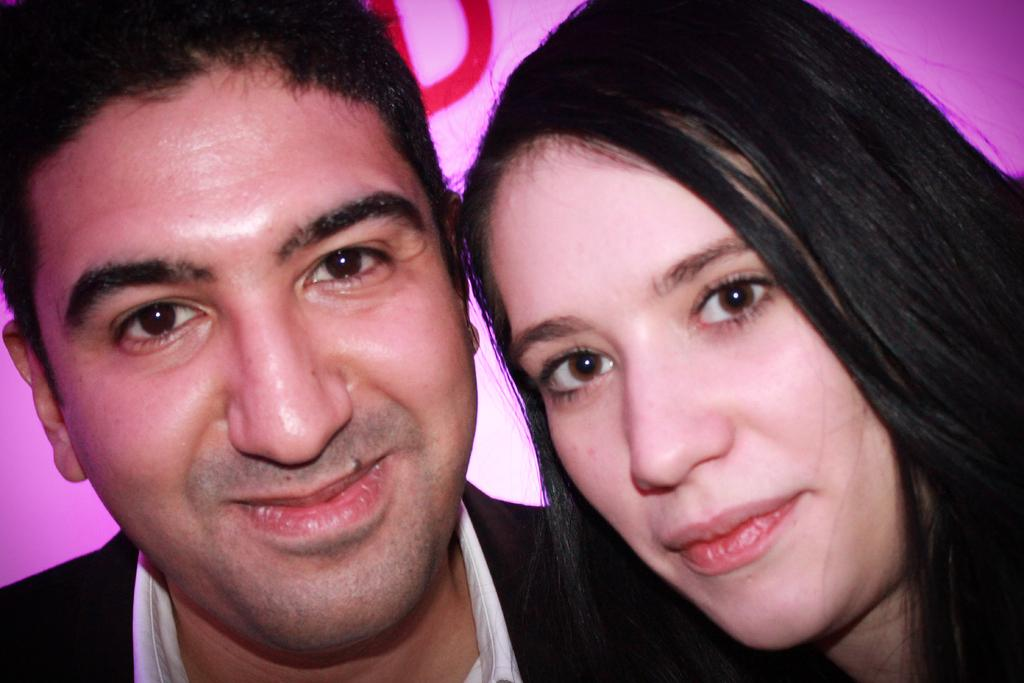Who is present in the image? There is a man and a beautiful girl in the image. Where is the man located in the image? The man is on the left side of the image. What direction is the man looking in? The man is looking to the right side. Who is beside the man in the image? The beautiful girl is beside the man. What direction is the girl looking in? The girl is also looking to the right side. How many ants can be seen crawling on the country in the image? There are no ants or countries present in the image. Is there a drawer visible in the image? There is no drawer present in the image. 